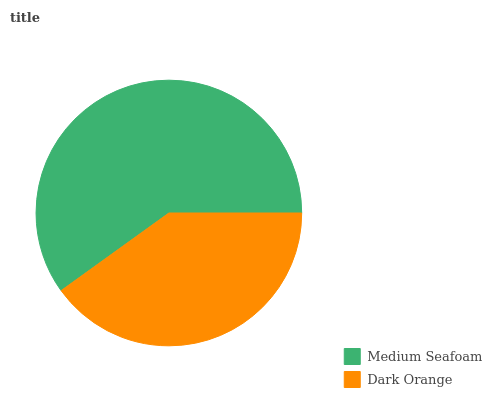Is Dark Orange the minimum?
Answer yes or no. Yes. Is Medium Seafoam the maximum?
Answer yes or no. Yes. Is Dark Orange the maximum?
Answer yes or no. No. Is Medium Seafoam greater than Dark Orange?
Answer yes or no. Yes. Is Dark Orange less than Medium Seafoam?
Answer yes or no. Yes. Is Dark Orange greater than Medium Seafoam?
Answer yes or no. No. Is Medium Seafoam less than Dark Orange?
Answer yes or no. No. Is Medium Seafoam the high median?
Answer yes or no. Yes. Is Dark Orange the low median?
Answer yes or no. Yes. Is Dark Orange the high median?
Answer yes or no. No. Is Medium Seafoam the low median?
Answer yes or no. No. 